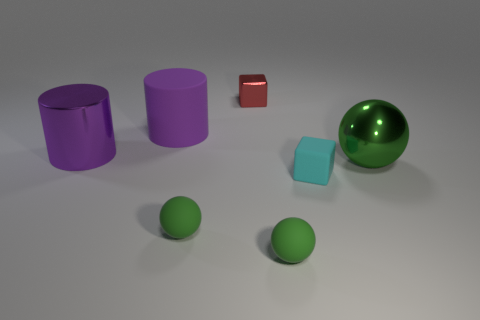Subtract all green metallic spheres. How many spheres are left? 2 Subtract all spheres. How many objects are left? 4 Add 2 large red rubber things. How many objects exist? 9 Subtract 1 cylinders. How many cylinders are left? 1 Subtract all big purple cylinders. Subtract all big metallic cylinders. How many objects are left? 4 Add 3 tiny matte objects. How many tiny matte objects are left? 6 Add 3 cubes. How many cubes exist? 5 Subtract 1 cyan cubes. How many objects are left? 6 Subtract all green cylinders. Subtract all red blocks. How many cylinders are left? 2 Subtract all green cylinders. How many red blocks are left? 1 